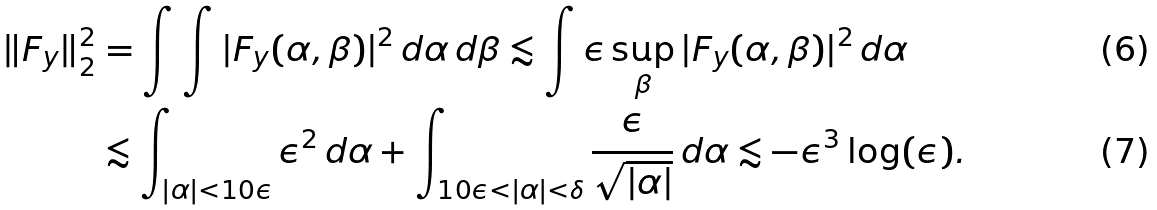<formula> <loc_0><loc_0><loc_500><loc_500>\| F _ { y } \| _ { 2 } ^ { 2 } & = \int \int | F _ { y } ( \alpha , \beta ) | ^ { 2 } \, d \alpha \, d \beta \lesssim \int \epsilon \sup _ { \beta } | F _ { y } ( \alpha , \beta ) | ^ { 2 } \, d \alpha \\ & \lesssim \int _ { | \alpha | < 1 0 \epsilon } \epsilon ^ { 2 } \, d \alpha + \int _ { 1 0 \epsilon < | \alpha | < \delta } \frac { \epsilon } { \sqrt { | \alpha | } } \, d \alpha \lesssim - \epsilon ^ { 3 } \log ( \epsilon ) .</formula> 